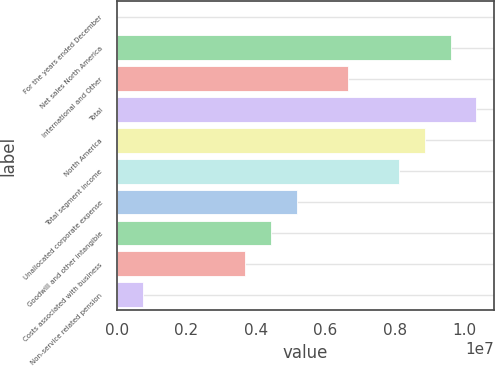Convert chart to OTSL. <chart><loc_0><loc_0><loc_500><loc_500><bar_chart><fcel>For the years ended December<fcel>Net sales North America<fcel>International and Other<fcel>Total<fcel>North America<fcel>Total segment income<fcel>Unallocated corporate expense<fcel>Goodwill and other intangible<fcel>Costs associated with business<fcel>Non-service related pension<nl><fcel>2015<fcel>9.60201e+06<fcel>6.64816e+06<fcel>1.03405e+07<fcel>8.86355e+06<fcel>8.12509e+06<fcel>5.17124e+06<fcel>4.43278e+06<fcel>3.69432e+06<fcel>740476<nl></chart> 